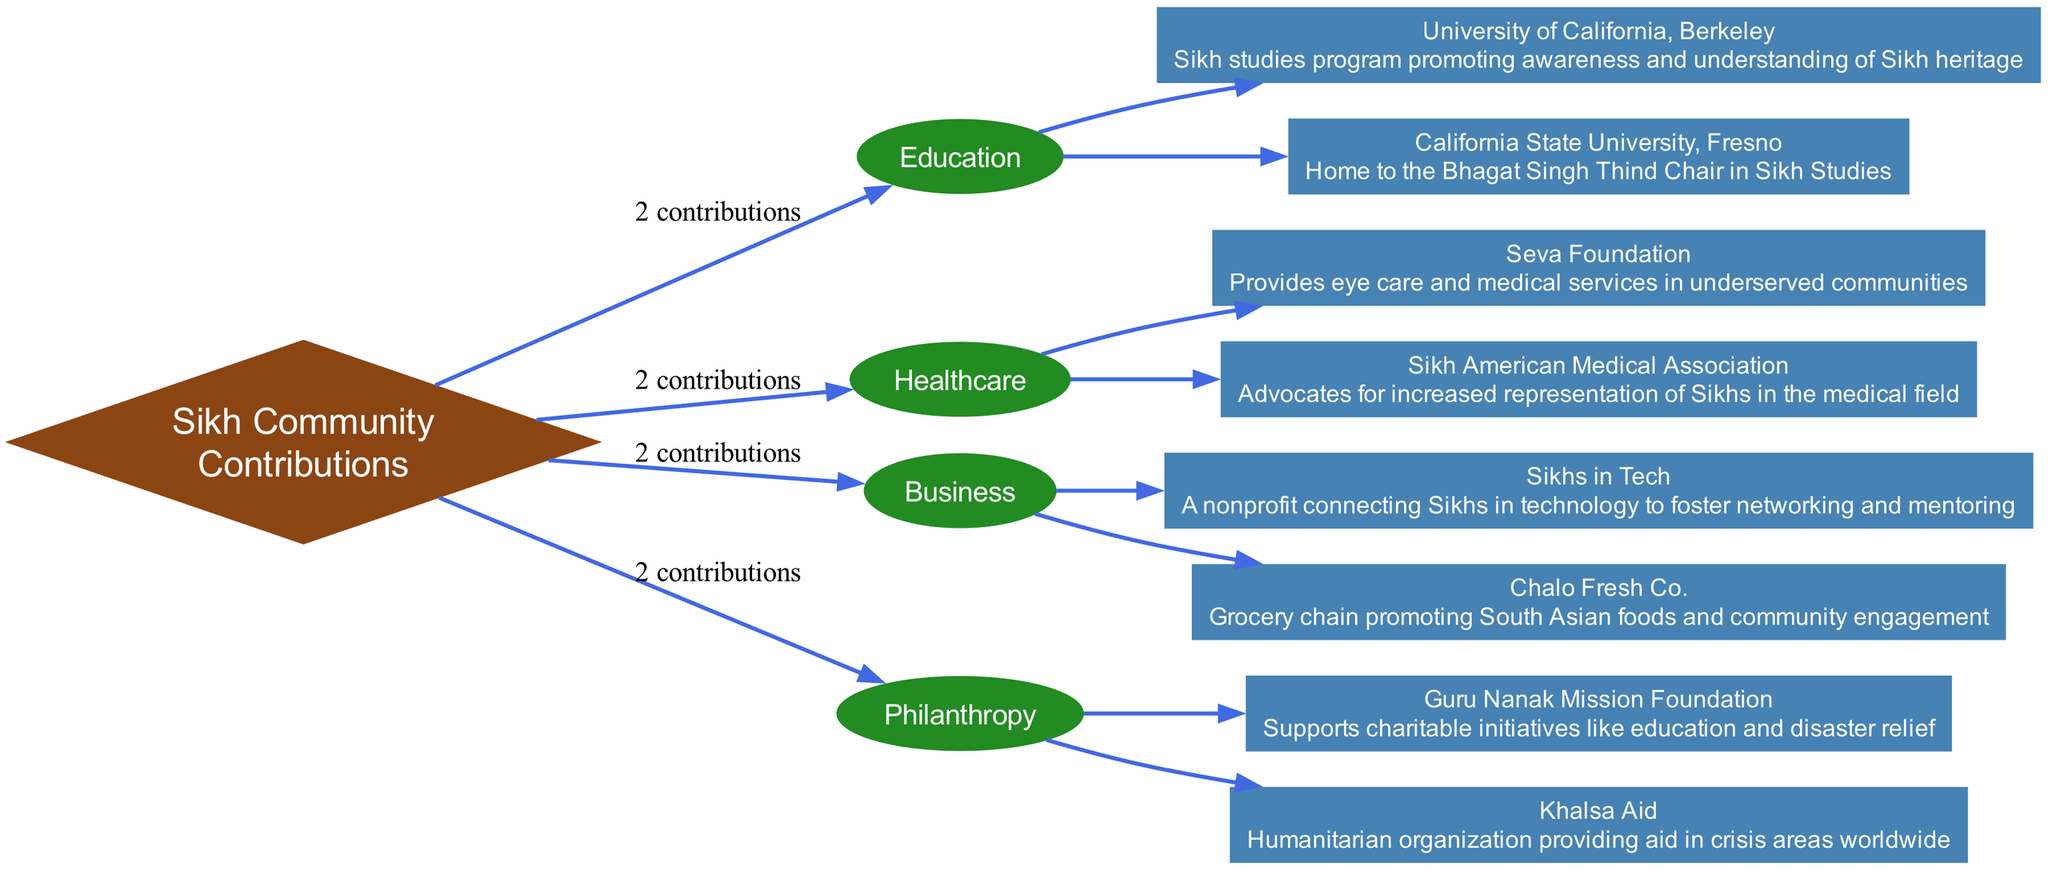What sectors are represented in the diagram? The diagram represents four sectors: Education, Healthcare, Business, and Philanthropy. Each sector has a clear connection to the central "Sikh Community" node, indicating their contributions.
Answer: Education, Healthcare, Business, Philanthropy How many contributions are listed under Healthcare? In the Healthcare sector, there are two contributions mentioned: Seva Foundation and Sikh American Medical Association. The number of contributions is indicated by the label on the edge connecting Healthcare to the Sikh Community node.
Answer: 2 Which organization is known for providing humanitarian aid in crisis areas? Khalsa Aid is identified in the Philanthropy sector as the organization providing humanitarian aid globally. This can be available by looking at the specific contributions listed underneath Philanthropy.
Answer: Khalsa Aid What is the main goal of Sikhs in Tech? Sikhs in Tech aims to connect Sikhs in technology for networking and mentoring. This can be found in the Business sector under the contributions listed.
Answer: Networking and mentoring How many total organizations are highlighted in the Education sector? The Education sector features two organizations: University of California, Berkeley and California State University, Fresno. This is also represented by the label indicating the number of contributions linked to this sector in the diagram.
Answer: 2 Which sector focuses on eye care and medical services? The Healthcare sector is associated with the Seva Foundation, which provides eye care and medical services in underserved communities. The information captures the contributions listed under Healthcare.
Answer: Healthcare Identify the entity responsible for the Sikh studies program. The University of California, Berkeley is responsible for promoting awareness and understanding of Sikh heritage through its Sikh studies program located in the Education sector of the diagram.
Answer: University of California, Berkeley Which contribution indicates a focus on South Asian foods? Chalo Fresh Co. is the contribution that promotes South Asian foods and community engagement, found in the Business sector. The diagram connects this entity specifically under the Business sector contributions.
Answer: Chalo Fresh Co How many total contributions are presented across all sectors of the diagram? There are a total of eight contributions, with two each from Education and Healthcare, two from Business, and two from Philanthropy. Each sector's contributions can be summed based on their individual counts.
Answer: 8 